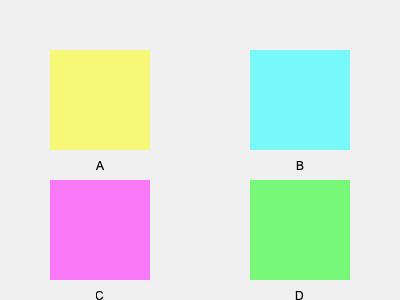Which lighting design is most likely to improve employee focus and reduce eye strain in an office environment? To determine the most effective lighting design for improving employee focus and reducing eye strain, we need to consider several factors:

1. Color temperature: Cooler light (bluish) tends to increase alertness and is better for daytime work, while warmer light (yellowish) is more relaxing and suitable for evening hours.

2. Brightness: Adequate brightness is necessary for visibility, but excessive brightness can cause glare and eye strain.

3. Diffusion: Well-diffused light reduces harsh shadows and glare, creating a more comfortable environment.

4. Natural light simulation: Lighting that mimics natural daylight can help maintain circadian rhythms and improve overall well-being.

Analyzing the options:

A (Yellow): Warm light, good for relaxation but may not promote alertness during work hours.
B (Cyan): Cool light, good for alertness but may be too intense if not properly diffused.
C (Magenta): Unnatural color, likely to cause eye strain and discomfort.
D (Green): Natural color, similar to leafy environments, promotes calmness and reduces eye strain.

Option D (Green) is the most suitable choice because:
1. It simulates a natural environment, which can reduce stress and eye strain.
2. Green light is in the middle of the visible spectrum, making it easier on the eyes.
3. It promotes a sense of calmness while maintaining adequate alertness for work.
4. The softer color is less likely to cause glare compared to brighter options like yellow or cyan.
Answer: D (Green) 